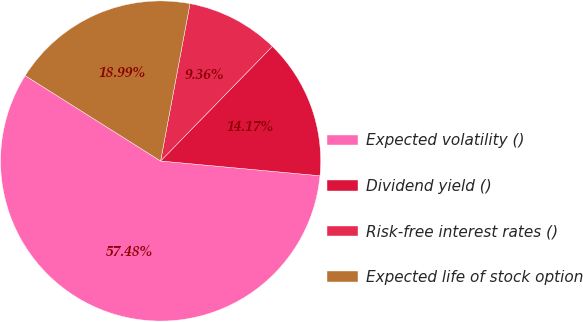Convert chart to OTSL. <chart><loc_0><loc_0><loc_500><loc_500><pie_chart><fcel>Expected volatility ()<fcel>Dividend yield ()<fcel>Risk-free interest rates ()<fcel>Expected life of stock option<nl><fcel>57.48%<fcel>14.17%<fcel>9.36%<fcel>18.99%<nl></chart> 